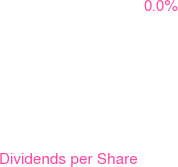Convert chart to OTSL. <chart><loc_0><loc_0><loc_500><loc_500><pie_chart><fcel>(in dollars split-adjusted)<fcel>Dividends per Share<nl><fcel>100.0%<fcel>0.0%<nl></chart> 